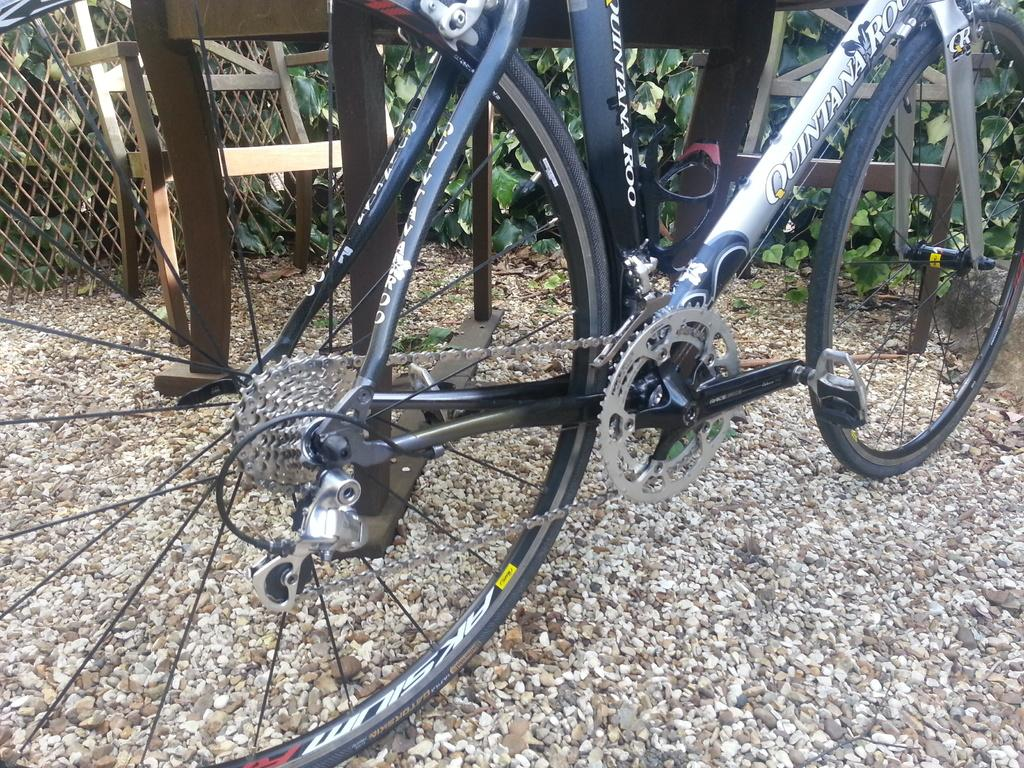What is the main object in the image? There is a bicycle in the image. What is the surface on which the bicycle is placed? The bicycle is on stones. What can be seen in the background of the image? There is a mesh, a chair, and plants in the background of the image. How many hands are visible in the image? There are no hands visible in the image. What type of bushes can be seen in the image? There are no bushes present in the image. 